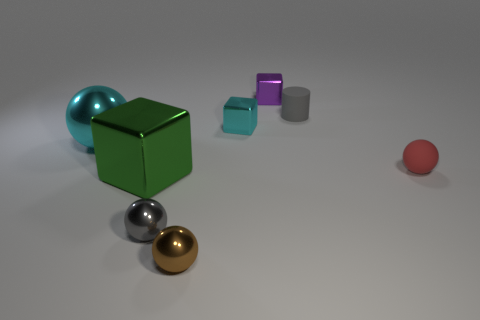Add 2 large blue rubber objects. How many objects exist? 10 Subtract all cylinders. How many objects are left? 7 Subtract 1 blocks. How many blocks are left? 2 Subtract all brown blocks. Subtract all brown cylinders. How many blocks are left? 3 Subtract all yellow cylinders. How many green balls are left? 0 Subtract all small cyan shiny things. Subtract all tiny cyan shiny blocks. How many objects are left? 6 Add 5 tiny brown objects. How many tiny brown objects are left? 6 Add 6 small gray cylinders. How many small gray cylinders exist? 7 Subtract all cyan spheres. How many spheres are left? 3 Subtract all large green metal blocks. How many blocks are left? 2 